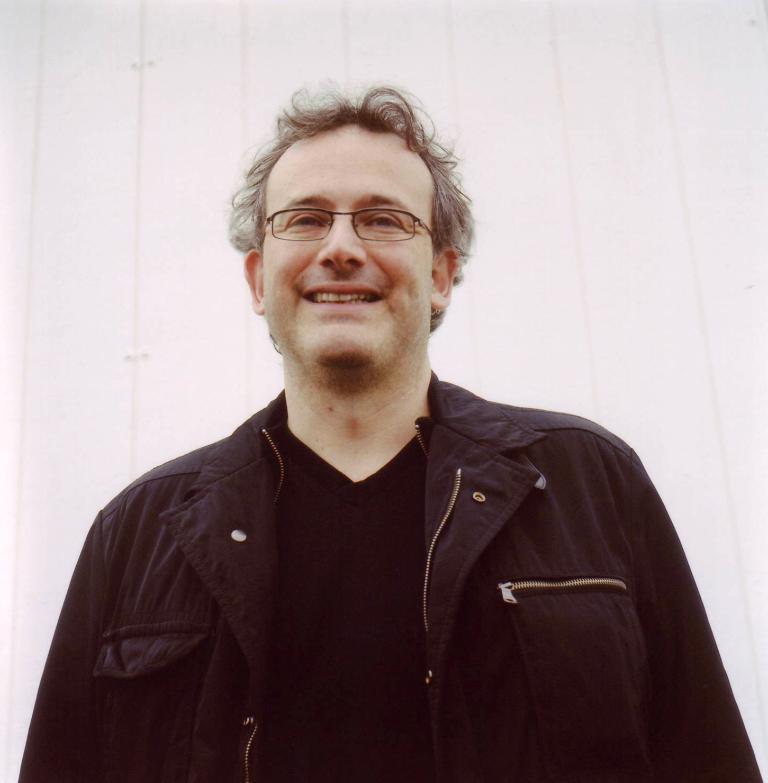Describe this image in one or two sentences. In this picture I can see a person wearing spectacles. 